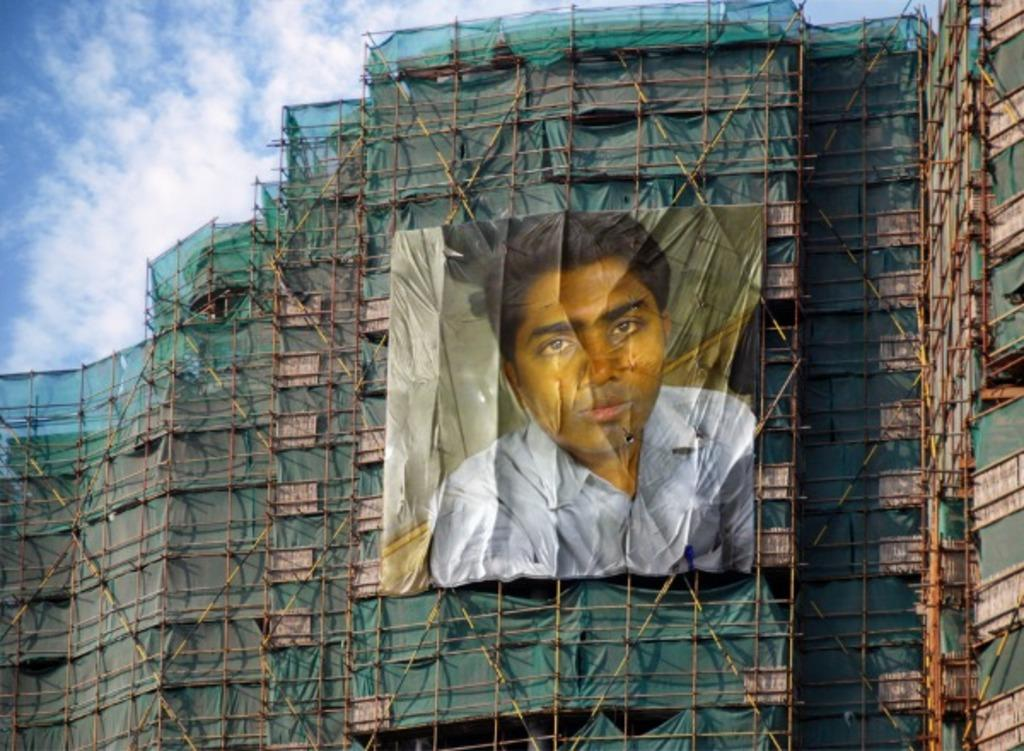What is depicted on the poster in the image? There is a poster of a person in the image. Where is the poster located? The poster is hanging on an under construction building. Can you describe the building in the image? The building has many poles. What can be seen in the background of the image? There is a green net in the image, and the sky is blue. What type of agreement is being signed in the image? There is no agreement being signed in the image; it features a poster of a person on an under construction building. How many chances does the person on the poster have to win a prize? There is no indication of a prize or chances in the image; it only shows a poster of a person on a building. 